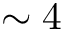<formula> <loc_0><loc_0><loc_500><loc_500>\sim 4</formula> 